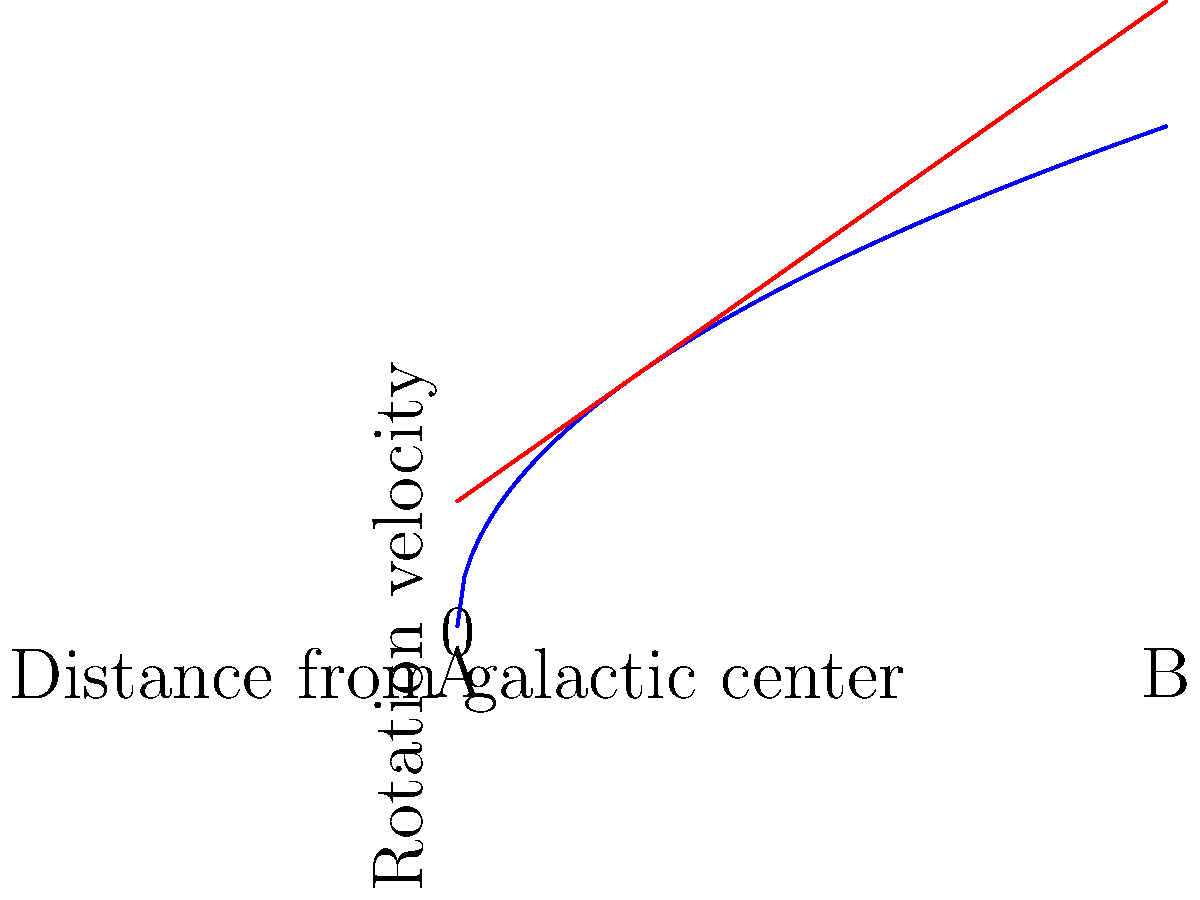Based on the rotation curves shown in the graph, which of the following statements best describes the dark matter content of this galaxy?

A) The galaxy contains little to no dark matter
B) The galaxy has a significant amount of dark matter To answer this question, we need to analyze the rotation curves presented in the graph:

1. The red line represents the expected Keplerian rotation curve, which would be observed if the galaxy's mass distribution followed only the visible matter.

2. The blue line represents the observed rotation curve of the galaxy.

3. In a galaxy without dark matter, we would expect the rotation velocity to decrease with distance from the galactic center, following the Keplerian curve (red line).

4. However, the observed rotation curve (blue line) remains relatively flat or even increases slightly at larger distances from the galactic center.

5. This discrepancy between the expected and observed rotation curves is known as the "galaxy rotation problem."

6. To explain this phenomenon, astronomers hypothesize the presence of dark matter in galaxies.

7. Dark matter provides additional mass that is not visible but contributes to the gravitational field, causing the rotation velocities to remain high at larger radii.

8. The significant difference between the observed and expected curves in this graph indicates a substantial amount of dark matter in the galaxy.

Therefore, the correct answer is B: The galaxy has a significant amount of dark matter.
Answer: B 